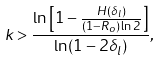Convert formula to latex. <formula><loc_0><loc_0><loc_500><loc_500>k > \frac { \ln \left [ 1 - \frac { H ( \delta _ { l } ) } { ( 1 - R _ { o } ) \ln 2 } \right ] } { \ln ( 1 - 2 \delta _ { l } ) } ,</formula> 